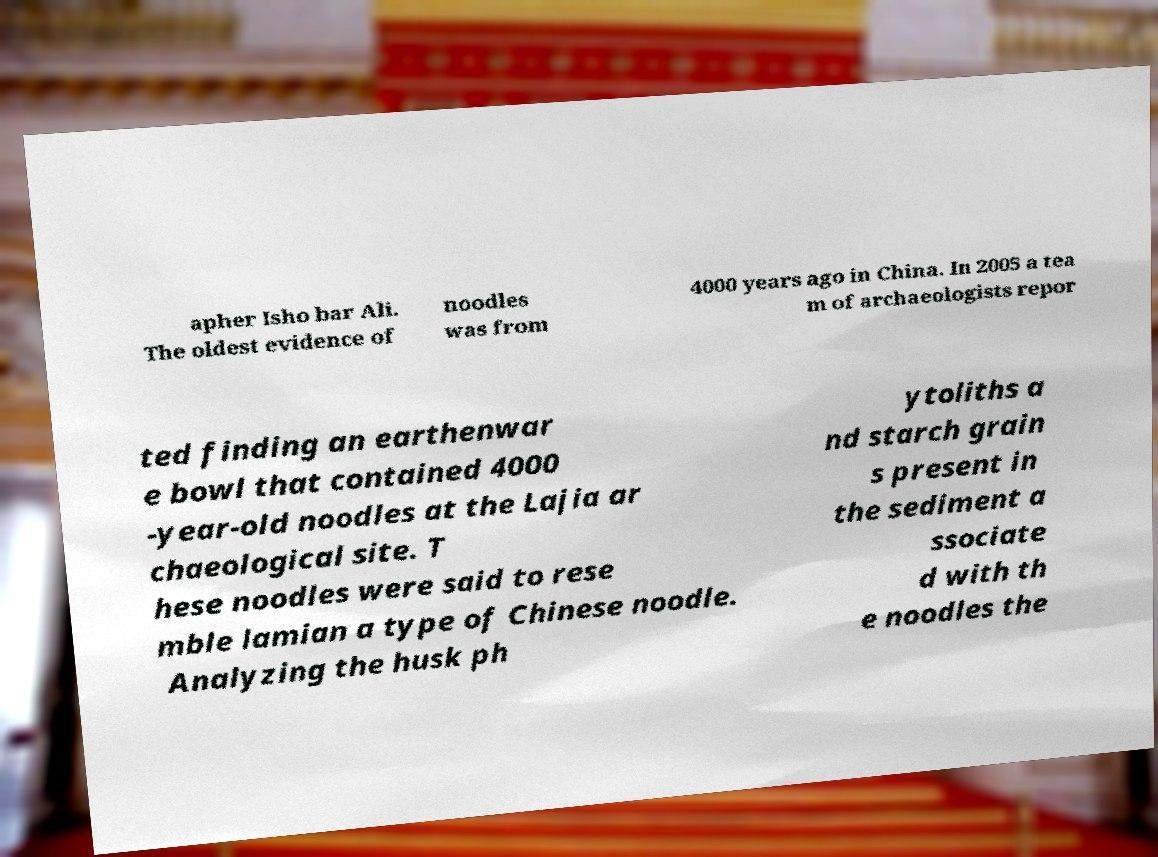For documentation purposes, I need the text within this image transcribed. Could you provide that? apher Isho bar Ali. The oldest evidence of noodles was from 4000 years ago in China. In 2005 a tea m of archaeologists repor ted finding an earthenwar e bowl that contained 4000 -year-old noodles at the Lajia ar chaeological site. T hese noodles were said to rese mble lamian a type of Chinese noodle. Analyzing the husk ph ytoliths a nd starch grain s present in the sediment a ssociate d with th e noodles the 